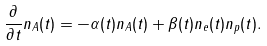Convert formula to latex. <formula><loc_0><loc_0><loc_500><loc_500>\frac { \partial } { \partial t } n _ { A } ( t ) = - \alpha ( t ) n _ { A } ( t ) + \beta ( t ) n _ { e } ( t ) n _ { p } ( t ) .</formula> 